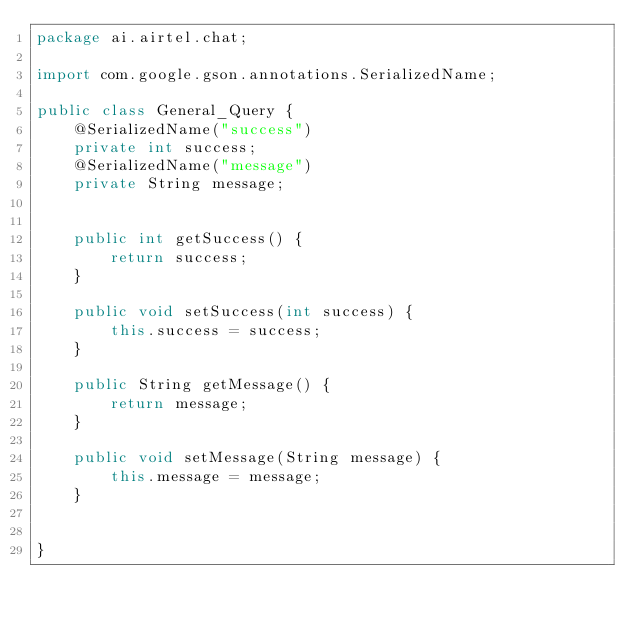<code> <loc_0><loc_0><loc_500><loc_500><_Java_>package ai.airtel.chat;

import com.google.gson.annotations.SerializedName;

public class General_Query {
    @SerializedName("success")
    private int success;
    @SerializedName("message")
    private String message;


    public int getSuccess() {
        return success;
    }

    public void setSuccess(int success) {
        this.success = success;
    }

    public String getMessage() {
        return message;
    }

    public void setMessage(String message) {
        this.message = message;
    }


}
</code> 